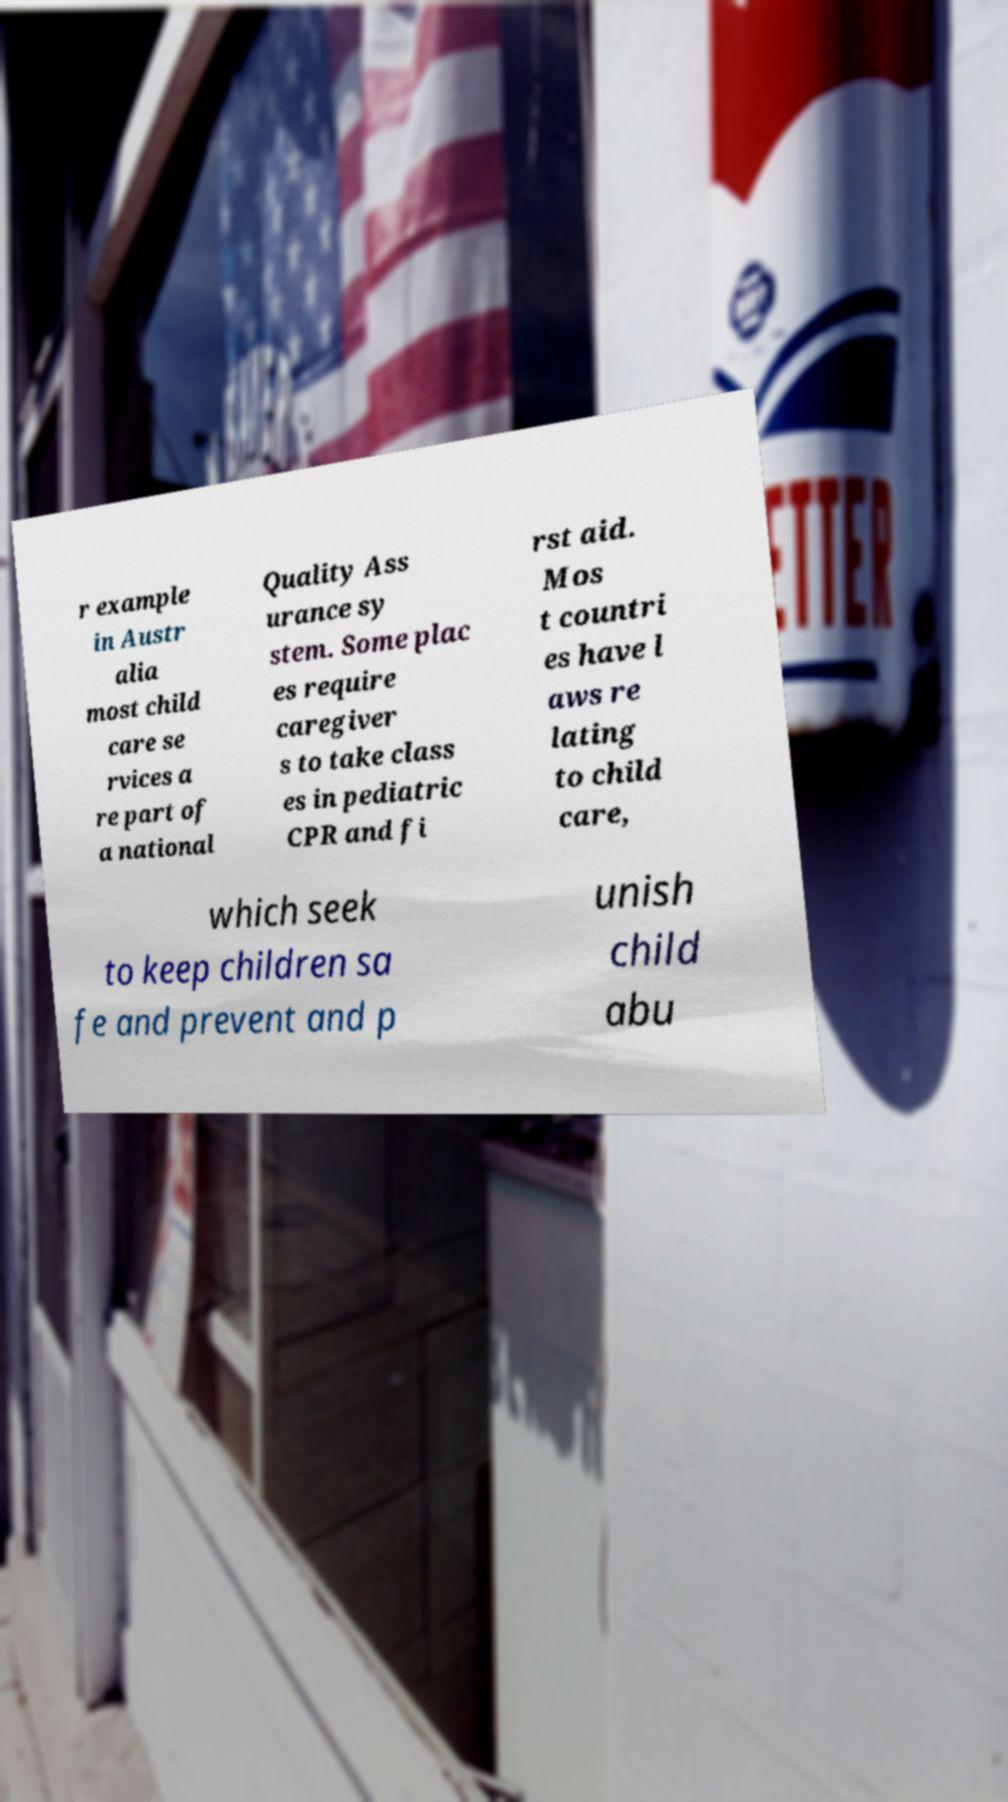There's text embedded in this image that I need extracted. Can you transcribe it verbatim? r example in Austr alia most child care se rvices a re part of a national Quality Ass urance sy stem. Some plac es require caregiver s to take class es in pediatric CPR and fi rst aid. Mos t countri es have l aws re lating to child care, which seek to keep children sa fe and prevent and p unish child abu 